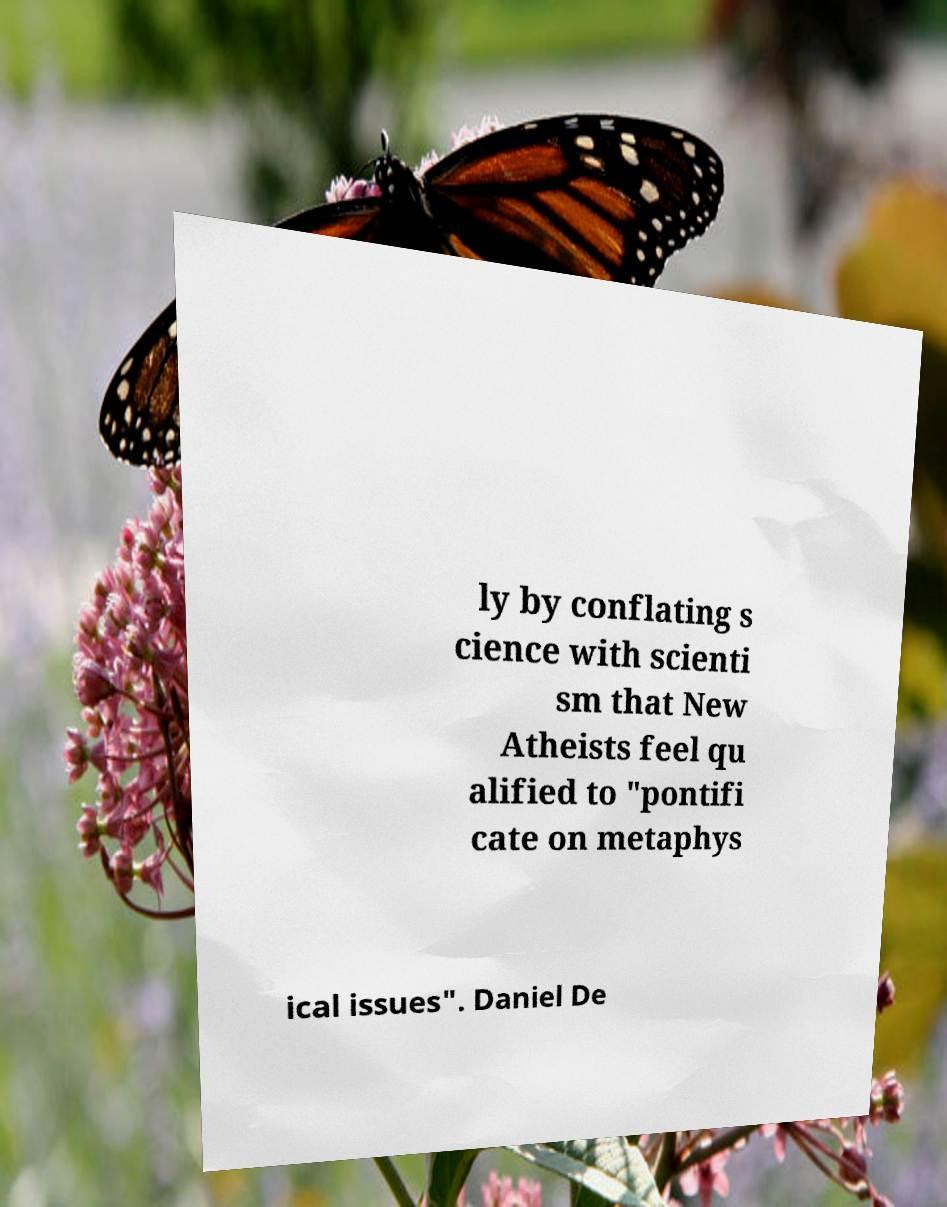Can you read and provide the text displayed in the image?This photo seems to have some interesting text. Can you extract and type it out for me? ly by conflating s cience with scienti sm that New Atheists feel qu alified to "pontifi cate on metaphys ical issues". Daniel De 